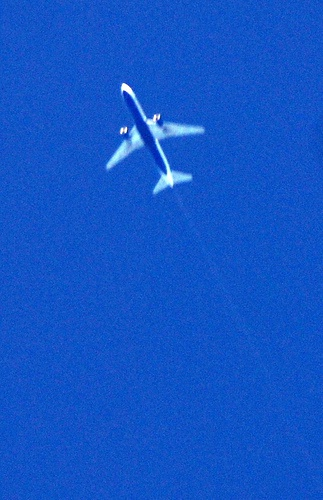Describe the objects in this image and their specific colors. I can see a airplane in blue and lightblue tones in this image. 